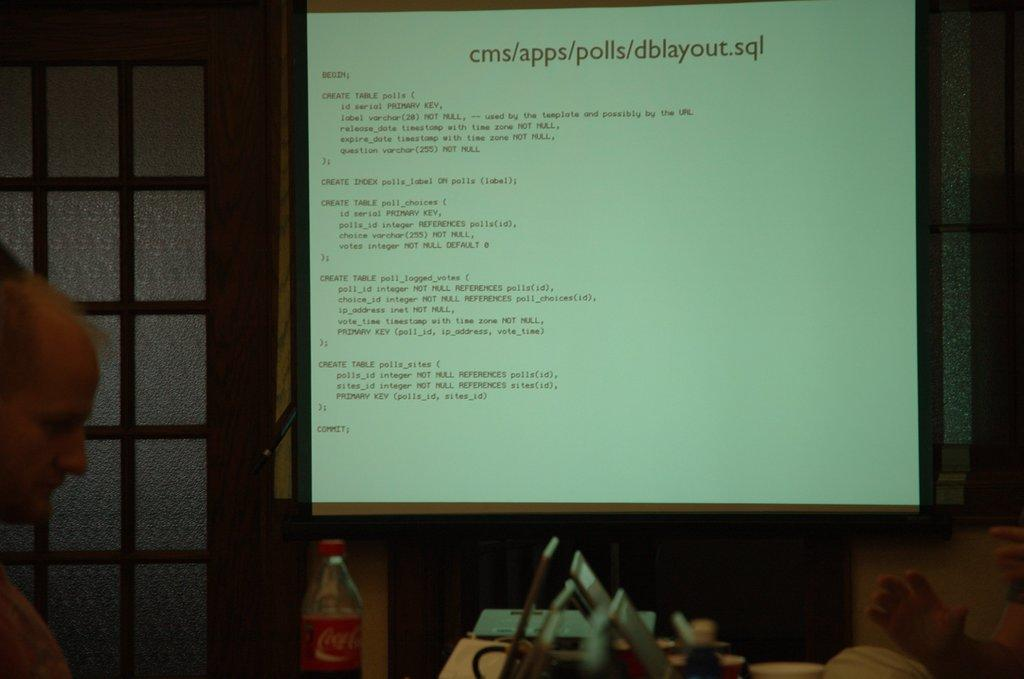<image>
Write a terse but informative summary of the picture. A projectors shows several lines of cms/apps/polls text as a man sits nearby. 